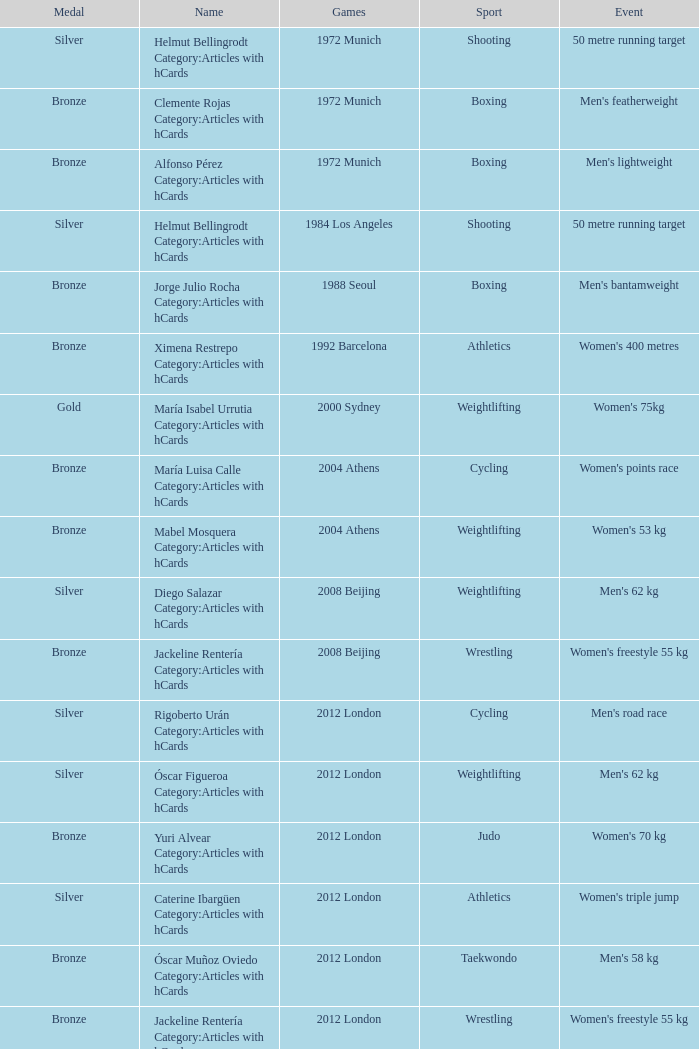What wrestling event was participated in during the 2008 Beijing games? Women's freestyle 55 kg. 